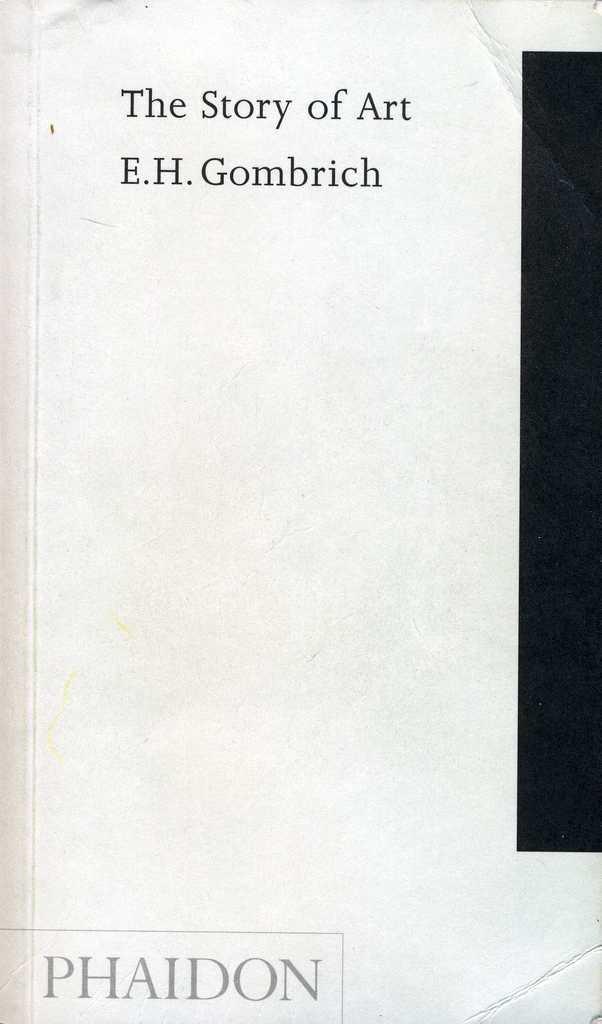How would you summarize this image in a sentence or two? In this picture we can see a cover page of a book. 